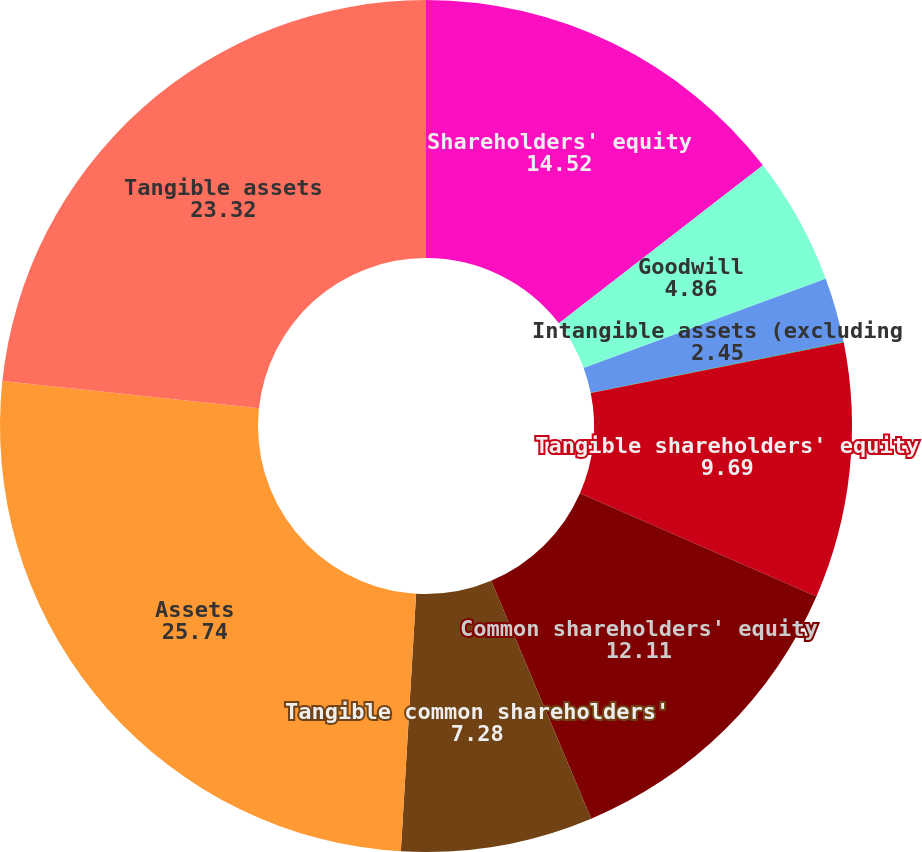Convert chart to OTSL. <chart><loc_0><loc_0><loc_500><loc_500><pie_chart><fcel>Shareholders' equity<fcel>Goodwill<fcel>Intangible assets (excluding<fcel>Related deferred tax<fcel>Tangible shareholders' equity<fcel>Common shareholders' equity<fcel>Tangible common shareholders'<fcel>Assets<fcel>Tangible assets<nl><fcel>14.52%<fcel>4.86%<fcel>2.45%<fcel>0.03%<fcel>9.69%<fcel>12.11%<fcel>7.28%<fcel>25.74%<fcel>23.32%<nl></chart> 